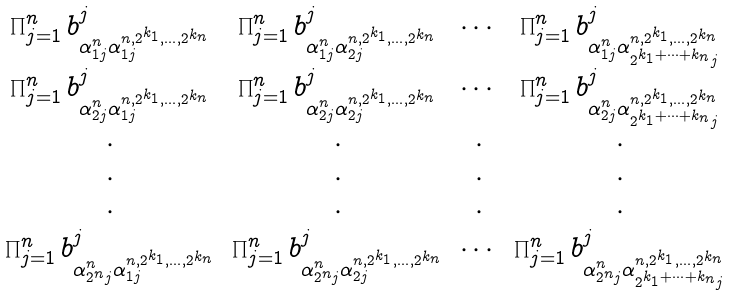<formula> <loc_0><loc_0><loc_500><loc_500>\begin{matrix} \prod _ { j = 1 } ^ { n } b _ { \alpha _ { 1 j } ^ { n } \alpha _ { 1 j } ^ { n , 2 ^ { k _ { 1 } } , \dots , 2 ^ { k _ { n } } } } ^ { j } & \prod _ { j = 1 } ^ { n } b _ { \alpha _ { 1 j } ^ { n } \alpha _ { 2 j } ^ { n , 2 ^ { k _ { 1 } } , \dots , 2 ^ { k _ { n } } } } ^ { j } & \cdots & \prod _ { j = 1 } ^ { n } b _ { \alpha _ { 1 j } ^ { n } \alpha _ { 2 ^ { k _ { 1 } + \cdots + k _ { n } } j } ^ { n , 2 ^ { k _ { 1 } } , \dots , 2 ^ { k _ { n } } } } ^ { j } \\ \prod _ { j = 1 } ^ { n } b _ { \alpha _ { 2 j } ^ { n } \alpha _ { 1 j } ^ { n , 2 ^ { k _ { 1 } } , \dots , 2 ^ { k _ { n } } } } ^ { j } & \prod _ { j = 1 } ^ { n } b _ { \alpha _ { 2 j } ^ { n } \alpha _ { 2 j } ^ { n , 2 ^ { k _ { 1 } } , \dots , 2 ^ { k _ { n } } } } ^ { j } & \cdots & \prod _ { j = 1 } ^ { n } b _ { \alpha _ { 2 j } ^ { n } \alpha _ { 2 ^ { k _ { 1 } + \cdots + k _ { n } } j } ^ { n , 2 ^ { k _ { 1 } } , \dots , 2 ^ { k _ { n } } } } ^ { j } \\ \cdot & \cdot & \cdot & \cdot \\ \cdot & \cdot & \cdot & \cdot \\ \cdot & \cdot & \cdot & \cdot \\ \prod _ { j = 1 } ^ { n } b _ { \alpha _ { 2 ^ { n } j } ^ { n } \alpha _ { 1 j } ^ { n , 2 ^ { k _ { 1 } } , \dots , 2 ^ { k _ { n } } } } ^ { j } & \prod _ { j = 1 } ^ { n } b _ { \alpha _ { 2 ^ { n } j } ^ { n } \alpha _ { 2 j } ^ { n , 2 ^ { k _ { 1 } } , \dots , 2 ^ { k _ { n } } } } ^ { j } & \cdots & \prod _ { j = 1 } ^ { n } b _ { \alpha _ { 2 ^ { n } j } ^ { n } \alpha _ { 2 ^ { k _ { 1 } + \cdots + k _ { n } } j } ^ { n , 2 ^ { k _ { 1 } } , \dots , 2 ^ { k _ { n } } } } ^ { j } \end{matrix}</formula> 